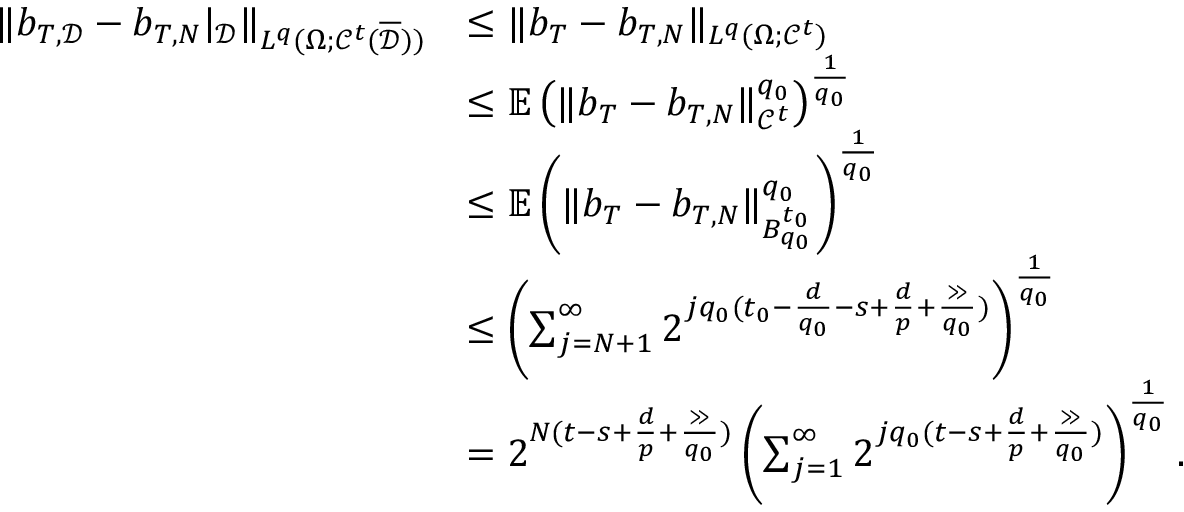<formula> <loc_0><loc_0><loc_500><loc_500>\begin{array} { r l } { \| b _ { T , \mathcal { D } } - b _ { T , N } | _ { \mathcal { D } } \| _ { L ^ { q } ( \Omega ; \mathcal { C } ^ { t } ( \overline { \mathcal { D } } ) ) } } & { \leq \| b _ { T } - b _ { T , N } \| _ { L ^ { q } ( \Omega ; \mathcal { C } ^ { t } ) } } \\ & { \leq \mathbb { E } \left ( \| b _ { T } - b _ { T , N } \| _ { \mathcal { C } ^ { t } } ^ { q _ { 0 } } \right ) ^ { \frac { 1 } { q _ { 0 } } } } \\ & { \leq \mathbb { E } \left ( \| b _ { T } - b _ { T , N } \| _ { B _ { q _ { 0 } } ^ { t _ { 0 } } } ^ { q _ { 0 } } \right ) ^ { \frac { 1 } { q _ { 0 } } } } \\ & { \leq \left ( \sum _ { j = N + 1 } ^ { \infty } 2 ^ { j q _ { 0 } ( t _ { 0 } - \frac { d } { q _ { 0 } } - s + \frac { d } { p } + \frac { \gg } { q _ { 0 } } ) } \right ) ^ { \frac { 1 } { q _ { 0 } } } } \\ & { = 2 ^ { N ( t - s + \frac { d } { p } + \frac { \gg } { q _ { 0 } } ) } \left ( \sum _ { j = 1 } ^ { \infty } 2 ^ { j q _ { 0 } ( t - s + \frac { d } { p } + \frac { \gg } { q _ { 0 } } ) } \right ) ^ { \frac { 1 } { q _ { 0 } } } . } \end{array}</formula> 